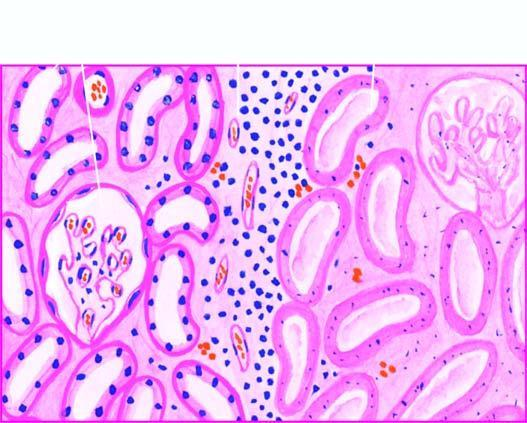do the tubular epithelial cells show granular debris?
Answer the question using a single word or phrase. No 